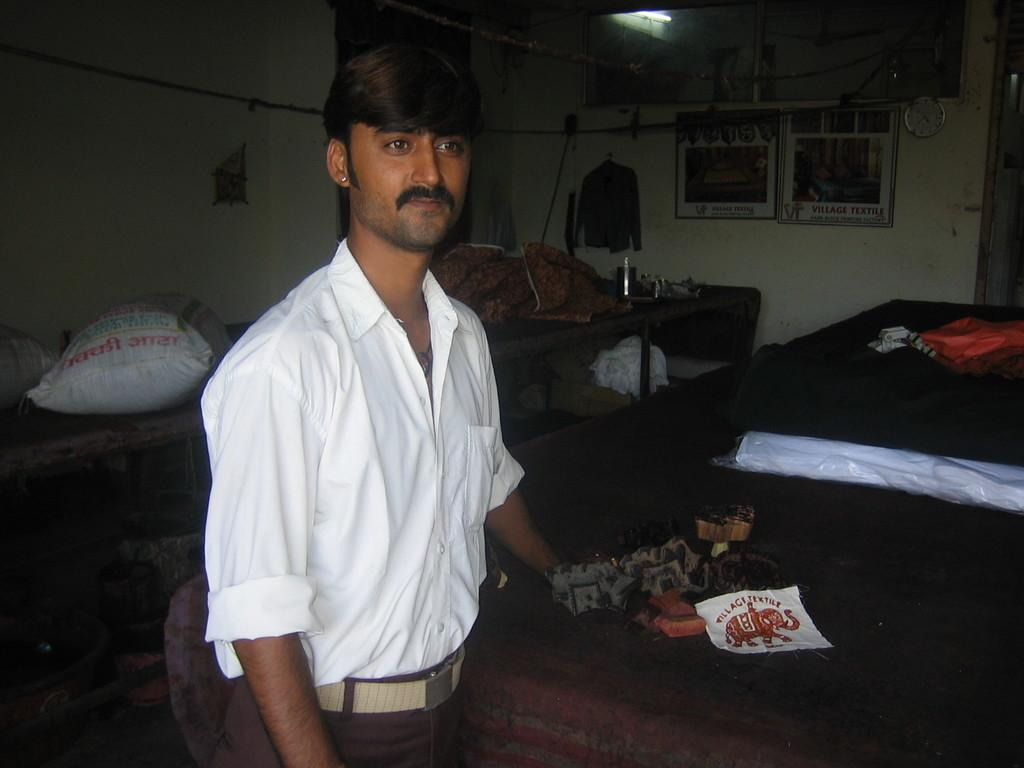What is the main subject of the image? There is a person standing in the center of the image. Where is the person standing? The person is standing on the floor. What can be seen in the background of the image? There is a bed, a clock, posters, a shirt, a table, a tube light, and a wall in the background of the image. What type of property is the person holding in the image? There is no property visible in the image; the person is not holding anything. Can you see any insects in the image? No, there are no insects present in the image. 